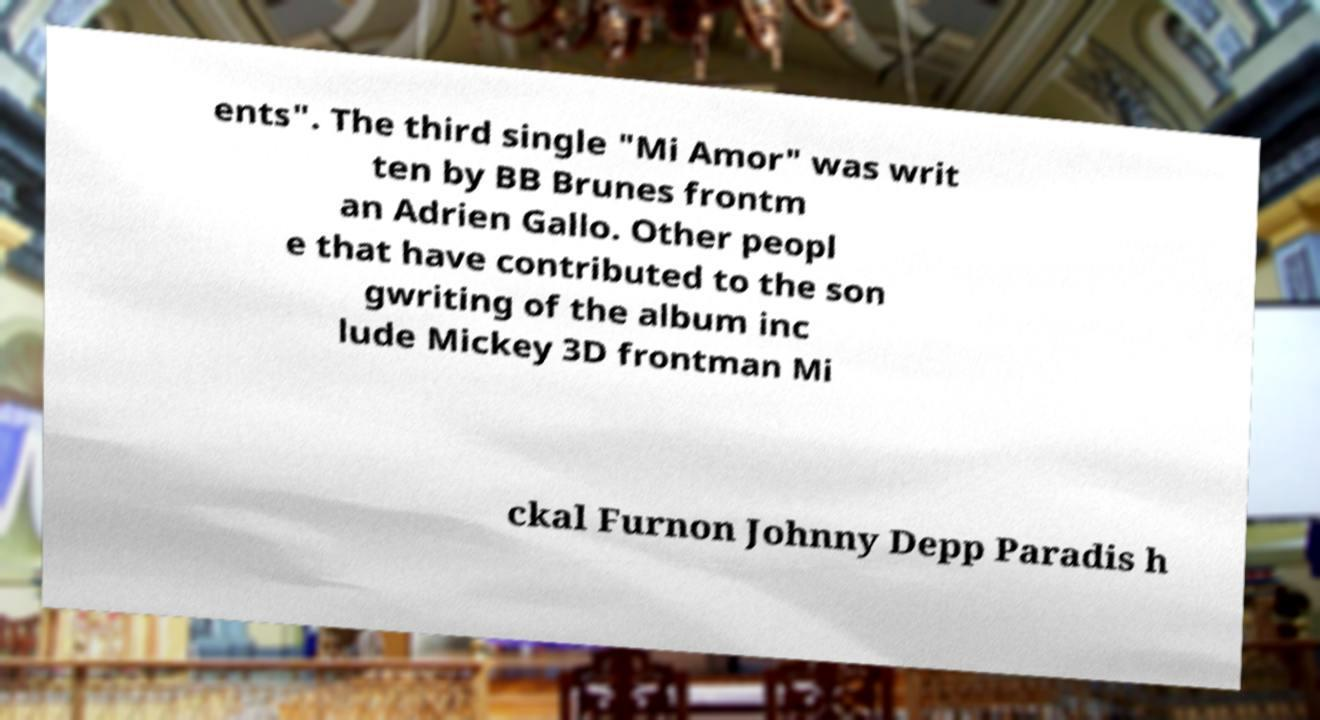I need the written content from this picture converted into text. Can you do that? ents". The third single "Mi Amor" was writ ten by BB Brunes frontm an Adrien Gallo. Other peopl e that have contributed to the son gwriting of the album inc lude Mickey 3D frontman Mi ckal Furnon Johnny Depp Paradis h 